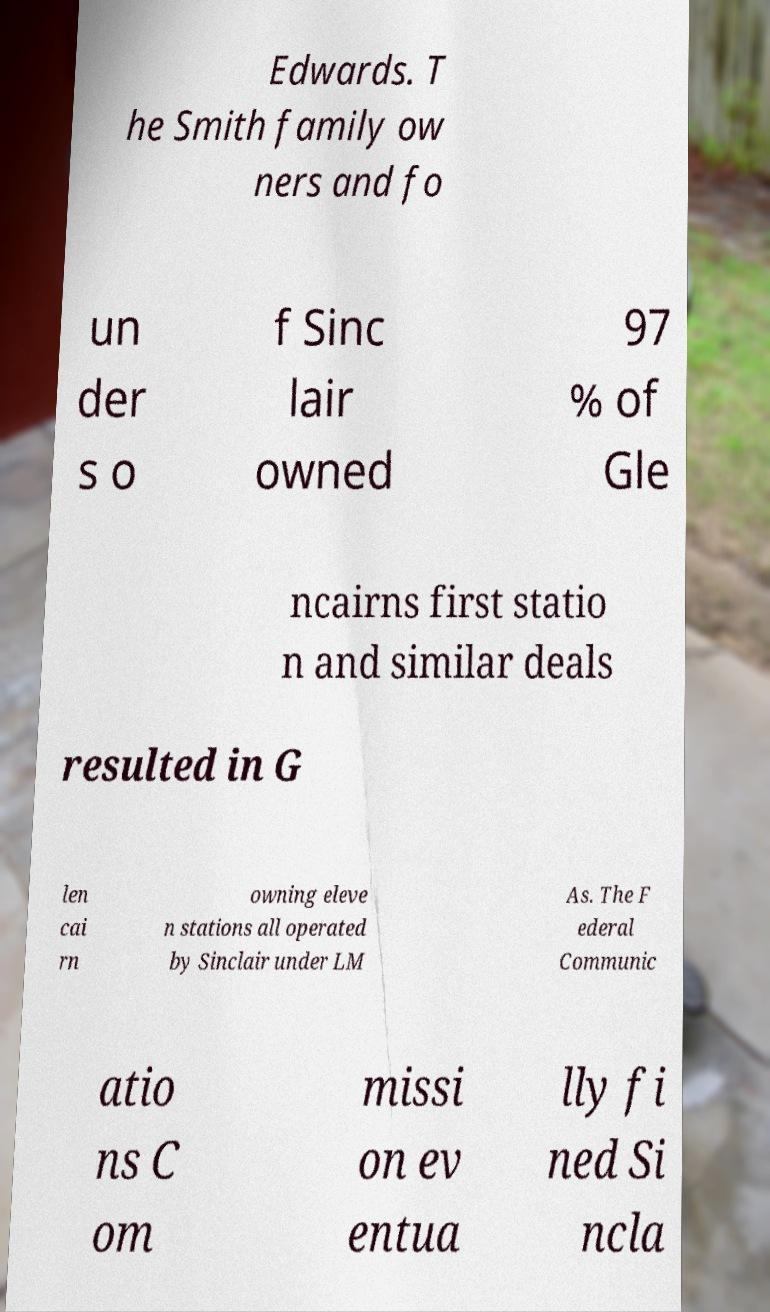For documentation purposes, I need the text within this image transcribed. Could you provide that? Edwards. T he Smith family ow ners and fo un der s o f Sinc lair owned 97 % of Gle ncairns first statio n and similar deals resulted in G len cai rn owning eleve n stations all operated by Sinclair under LM As. The F ederal Communic atio ns C om missi on ev entua lly fi ned Si ncla 